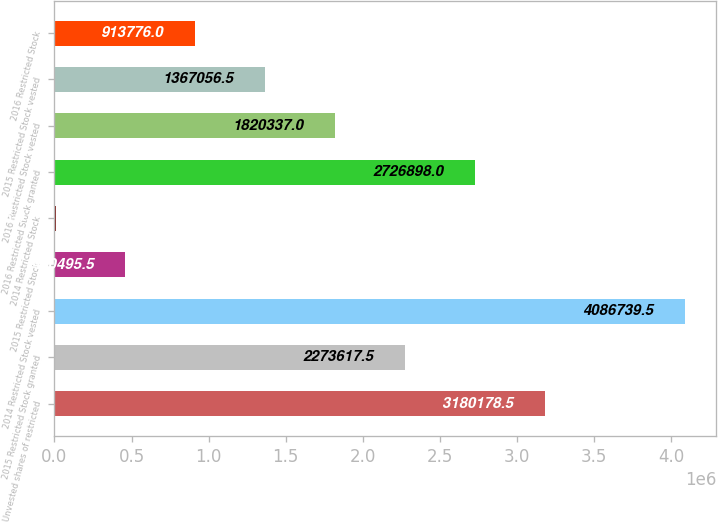Convert chart to OTSL. <chart><loc_0><loc_0><loc_500><loc_500><bar_chart><fcel>Unvested shares of restricted<fcel>2015 Restricted Stock granted<fcel>2014 Restricted Stock vested<fcel>2015 Restricted Stock<fcel>2014 Restricted Stock<fcel>2016 Restricted Stock granted<fcel>2016 Restricted Stock vested<fcel>2015 Restricted Stock vested<fcel>2016 Restricted Stock<nl><fcel>3.18018e+06<fcel>2.27362e+06<fcel>4.08674e+06<fcel>460496<fcel>7215<fcel>2.7269e+06<fcel>1.82034e+06<fcel>1.36706e+06<fcel>913776<nl></chart> 